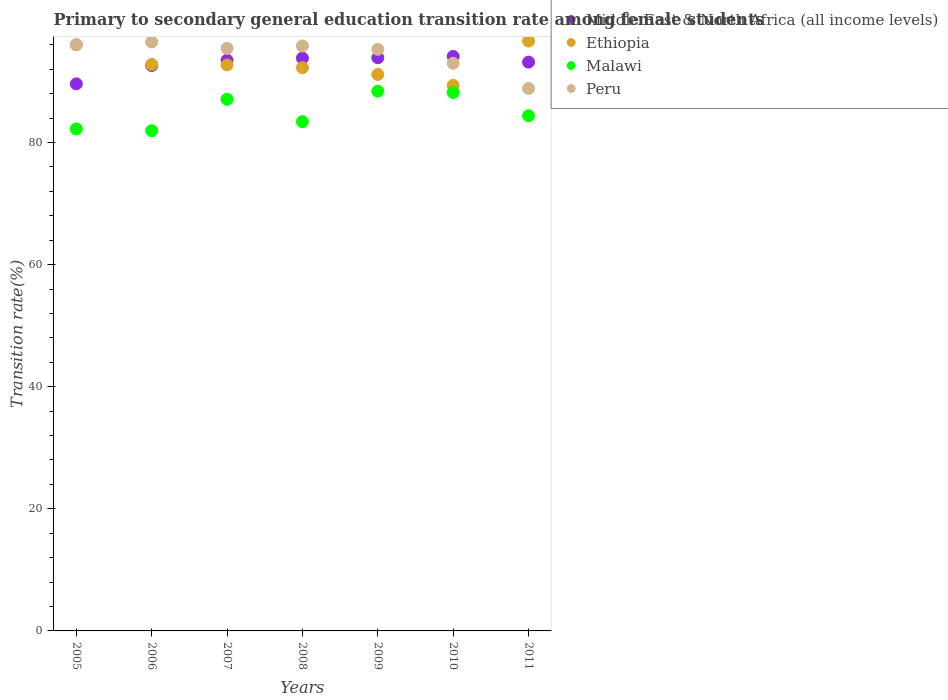How many different coloured dotlines are there?
Keep it short and to the point. 4. Is the number of dotlines equal to the number of legend labels?
Your answer should be compact. Yes. What is the transition rate in Peru in 2005?
Your answer should be compact. 96.03. Across all years, what is the maximum transition rate in Malawi?
Your answer should be very brief. 88.4. Across all years, what is the minimum transition rate in Ethiopia?
Offer a terse response. 89.35. In which year was the transition rate in Malawi maximum?
Ensure brevity in your answer.  2009. What is the total transition rate in Ethiopia in the graph?
Offer a terse response. 650.88. What is the difference between the transition rate in Middle East & North Africa (all income levels) in 2007 and that in 2008?
Your answer should be compact. -0.34. What is the difference between the transition rate in Middle East & North Africa (all income levels) in 2010 and the transition rate in Malawi in 2008?
Provide a short and direct response. 10.69. What is the average transition rate in Middle East & North Africa (all income levels) per year?
Provide a short and direct response. 92.96. In the year 2005, what is the difference between the transition rate in Malawi and transition rate in Ethiopia?
Make the answer very short. -13.78. In how many years, is the transition rate in Ethiopia greater than 48 %?
Offer a terse response. 7. What is the ratio of the transition rate in Peru in 2005 to that in 2007?
Offer a terse response. 1.01. Is the transition rate in Ethiopia in 2005 less than that in 2011?
Offer a terse response. Yes. What is the difference between the highest and the second highest transition rate in Malawi?
Offer a very short reply. 0.21. What is the difference between the highest and the lowest transition rate in Middle East & North Africa (all income levels)?
Your answer should be compact. 4.49. In how many years, is the transition rate in Malawi greater than the average transition rate in Malawi taken over all years?
Your answer should be very brief. 3. Is the sum of the transition rate in Malawi in 2009 and 2010 greater than the maximum transition rate in Peru across all years?
Offer a terse response. Yes. Is it the case that in every year, the sum of the transition rate in Peru and transition rate in Ethiopia  is greater than the sum of transition rate in Malawi and transition rate in Middle East & North Africa (all income levels)?
Offer a terse response. No. Is the transition rate in Ethiopia strictly less than the transition rate in Malawi over the years?
Provide a short and direct response. No. How many dotlines are there?
Offer a very short reply. 4. How many years are there in the graph?
Offer a terse response. 7. Are the values on the major ticks of Y-axis written in scientific E-notation?
Offer a terse response. No. Does the graph contain any zero values?
Offer a very short reply. No. Does the graph contain grids?
Provide a succinct answer. No. How are the legend labels stacked?
Your answer should be very brief. Vertical. What is the title of the graph?
Provide a succinct answer. Primary to secondary general education transition rate among female students. Does "Low income" appear as one of the legend labels in the graph?
Your answer should be very brief. No. What is the label or title of the Y-axis?
Keep it short and to the point. Transition rate(%). What is the Transition rate(%) in Middle East & North Africa (all income levels) in 2005?
Keep it short and to the point. 89.61. What is the Transition rate(%) of Ethiopia in 2005?
Make the answer very short. 96.01. What is the Transition rate(%) in Malawi in 2005?
Provide a short and direct response. 82.23. What is the Transition rate(%) of Peru in 2005?
Your response must be concise. 96.03. What is the Transition rate(%) in Middle East & North Africa (all income levels) in 2006?
Keep it short and to the point. 92.61. What is the Transition rate(%) in Ethiopia in 2006?
Offer a very short reply. 92.79. What is the Transition rate(%) of Malawi in 2006?
Provide a succinct answer. 81.94. What is the Transition rate(%) in Peru in 2006?
Make the answer very short. 96.47. What is the Transition rate(%) in Middle East & North Africa (all income levels) in 2007?
Keep it short and to the point. 93.48. What is the Transition rate(%) in Ethiopia in 2007?
Your response must be concise. 92.71. What is the Transition rate(%) of Malawi in 2007?
Make the answer very short. 87.08. What is the Transition rate(%) in Peru in 2007?
Your response must be concise. 95.42. What is the Transition rate(%) in Middle East & North Africa (all income levels) in 2008?
Offer a terse response. 93.82. What is the Transition rate(%) of Ethiopia in 2008?
Keep it short and to the point. 92.26. What is the Transition rate(%) in Malawi in 2008?
Provide a succinct answer. 83.41. What is the Transition rate(%) in Peru in 2008?
Keep it short and to the point. 95.81. What is the Transition rate(%) in Middle East & North Africa (all income levels) in 2009?
Your response must be concise. 93.88. What is the Transition rate(%) of Ethiopia in 2009?
Your response must be concise. 91.15. What is the Transition rate(%) of Malawi in 2009?
Provide a succinct answer. 88.4. What is the Transition rate(%) of Peru in 2009?
Offer a terse response. 95.26. What is the Transition rate(%) in Middle East & North Africa (all income levels) in 2010?
Make the answer very short. 94.11. What is the Transition rate(%) of Ethiopia in 2010?
Provide a short and direct response. 89.35. What is the Transition rate(%) in Malawi in 2010?
Ensure brevity in your answer.  88.19. What is the Transition rate(%) in Peru in 2010?
Your response must be concise. 92.99. What is the Transition rate(%) of Middle East & North Africa (all income levels) in 2011?
Give a very brief answer. 93.17. What is the Transition rate(%) in Ethiopia in 2011?
Keep it short and to the point. 96.62. What is the Transition rate(%) of Malawi in 2011?
Provide a short and direct response. 84.39. What is the Transition rate(%) in Peru in 2011?
Your response must be concise. 88.85. Across all years, what is the maximum Transition rate(%) of Middle East & North Africa (all income levels)?
Keep it short and to the point. 94.11. Across all years, what is the maximum Transition rate(%) of Ethiopia?
Provide a short and direct response. 96.62. Across all years, what is the maximum Transition rate(%) of Malawi?
Keep it short and to the point. 88.4. Across all years, what is the maximum Transition rate(%) of Peru?
Give a very brief answer. 96.47. Across all years, what is the minimum Transition rate(%) of Middle East & North Africa (all income levels)?
Provide a succinct answer. 89.61. Across all years, what is the minimum Transition rate(%) of Ethiopia?
Your answer should be compact. 89.35. Across all years, what is the minimum Transition rate(%) in Malawi?
Your answer should be compact. 81.94. Across all years, what is the minimum Transition rate(%) in Peru?
Keep it short and to the point. 88.85. What is the total Transition rate(%) of Middle East & North Africa (all income levels) in the graph?
Keep it short and to the point. 650.69. What is the total Transition rate(%) in Ethiopia in the graph?
Keep it short and to the point. 650.88. What is the total Transition rate(%) in Malawi in the graph?
Offer a terse response. 595.64. What is the total Transition rate(%) of Peru in the graph?
Your response must be concise. 660.83. What is the difference between the Transition rate(%) in Middle East & North Africa (all income levels) in 2005 and that in 2006?
Your response must be concise. -3. What is the difference between the Transition rate(%) of Ethiopia in 2005 and that in 2006?
Your response must be concise. 3.21. What is the difference between the Transition rate(%) in Malawi in 2005 and that in 2006?
Offer a terse response. 0.29. What is the difference between the Transition rate(%) of Peru in 2005 and that in 2006?
Offer a terse response. -0.44. What is the difference between the Transition rate(%) in Middle East & North Africa (all income levels) in 2005 and that in 2007?
Keep it short and to the point. -3.87. What is the difference between the Transition rate(%) in Ethiopia in 2005 and that in 2007?
Provide a short and direct response. 3.3. What is the difference between the Transition rate(%) in Malawi in 2005 and that in 2007?
Your response must be concise. -4.85. What is the difference between the Transition rate(%) of Peru in 2005 and that in 2007?
Your answer should be very brief. 0.61. What is the difference between the Transition rate(%) in Middle East & North Africa (all income levels) in 2005 and that in 2008?
Make the answer very short. -4.21. What is the difference between the Transition rate(%) of Ethiopia in 2005 and that in 2008?
Provide a short and direct response. 3.75. What is the difference between the Transition rate(%) of Malawi in 2005 and that in 2008?
Offer a very short reply. -1.18. What is the difference between the Transition rate(%) of Peru in 2005 and that in 2008?
Offer a terse response. 0.22. What is the difference between the Transition rate(%) in Middle East & North Africa (all income levels) in 2005 and that in 2009?
Make the answer very short. -4.27. What is the difference between the Transition rate(%) of Ethiopia in 2005 and that in 2009?
Make the answer very short. 4.86. What is the difference between the Transition rate(%) in Malawi in 2005 and that in 2009?
Offer a terse response. -6.17. What is the difference between the Transition rate(%) of Peru in 2005 and that in 2009?
Give a very brief answer. 0.77. What is the difference between the Transition rate(%) in Middle East & North Africa (all income levels) in 2005 and that in 2010?
Offer a terse response. -4.49. What is the difference between the Transition rate(%) of Ethiopia in 2005 and that in 2010?
Offer a terse response. 6.65. What is the difference between the Transition rate(%) of Malawi in 2005 and that in 2010?
Offer a terse response. -5.96. What is the difference between the Transition rate(%) of Peru in 2005 and that in 2010?
Provide a succinct answer. 3.04. What is the difference between the Transition rate(%) of Middle East & North Africa (all income levels) in 2005 and that in 2011?
Offer a very short reply. -3.56. What is the difference between the Transition rate(%) in Ethiopia in 2005 and that in 2011?
Your answer should be very brief. -0.61. What is the difference between the Transition rate(%) of Malawi in 2005 and that in 2011?
Ensure brevity in your answer.  -2.16. What is the difference between the Transition rate(%) of Peru in 2005 and that in 2011?
Offer a terse response. 7.18. What is the difference between the Transition rate(%) in Middle East & North Africa (all income levels) in 2006 and that in 2007?
Keep it short and to the point. -0.87. What is the difference between the Transition rate(%) of Ethiopia in 2006 and that in 2007?
Make the answer very short. 0.08. What is the difference between the Transition rate(%) in Malawi in 2006 and that in 2007?
Provide a short and direct response. -5.14. What is the difference between the Transition rate(%) of Peru in 2006 and that in 2007?
Your answer should be very brief. 1.05. What is the difference between the Transition rate(%) of Middle East & North Africa (all income levels) in 2006 and that in 2008?
Ensure brevity in your answer.  -1.21. What is the difference between the Transition rate(%) in Ethiopia in 2006 and that in 2008?
Provide a short and direct response. 0.53. What is the difference between the Transition rate(%) in Malawi in 2006 and that in 2008?
Your response must be concise. -1.47. What is the difference between the Transition rate(%) of Peru in 2006 and that in 2008?
Offer a terse response. 0.66. What is the difference between the Transition rate(%) of Middle East & North Africa (all income levels) in 2006 and that in 2009?
Provide a succinct answer. -1.27. What is the difference between the Transition rate(%) of Ethiopia in 2006 and that in 2009?
Make the answer very short. 1.65. What is the difference between the Transition rate(%) of Malawi in 2006 and that in 2009?
Provide a succinct answer. -6.46. What is the difference between the Transition rate(%) in Peru in 2006 and that in 2009?
Make the answer very short. 1.21. What is the difference between the Transition rate(%) in Middle East & North Africa (all income levels) in 2006 and that in 2010?
Provide a short and direct response. -1.49. What is the difference between the Transition rate(%) of Ethiopia in 2006 and that in 2010?
Keep it short and to the point. 3.44. What is the difference between the Transition rate(%) in Malawi in 2006 and that in 2010?
Give a very brief answer. -6.25. What is the difference between the Transition rate(%) of Peru in 2006 and that in 2010?
Provide a short and direct response. 3.48. What is the difference between the Transition rate(%) of Middle East & North Africa (all income levels) in 2006 and that in 2011?
Give a very brief answer. -0.56. What is the difference between the Transition rate(%) in Ethiopia in 2006 and that in 2011?
Provide a succinct answer. -3.83. What is the difference between the Transition rate(%) in Malawi in 2006 and that in 2011?
Make the answer very short. -2.45. What is the difference between the Transition rate(%) of Peru in 2006 and that in 2011?
Your answer should be compact. 7.62. What is the difference between the Transition rate(%) of Middle East & North Africa (all income levels) in 2007 and that in 2008?
Your answer should be very brief. -0.34. What is the difference between the Transition rate(%) in Ethiopia in 2007 and that in 2008?
Give a very brief answer. 0.45. What is the difference between the Transition rate(%) in Malawi in 2007 and that in 2008?
Offer a terse response. 3.67. What is the difference between the Transition rate(%) of Peru in 2007 and that in 2008?
Your answer should be compact. -0.39. What is the difference between the Transition rate(%) in Middle East & North Africa (all income levels) in 2007 and that in 2009?
Offer a terse response. -0.4. What is the difference between the Transition rate(%) in Ethiopia in 2007 and that in 2009?
Your answer should be very brief. 1.56. What is the difference between the Transition rate(%) in Malawi in 2007 and that in 2009?
Your answer should be compact. -1.33. What is the difference between the Transition rate(%) of Peru in 2007 and that in 2009?
Your answer should be compact. 0.16. What is the difference between the Transition rate(%) in Middle East & North Africa (all income levels) in 2007 and that in 2010?
Offer a very short reply. -0.62. What is the difference between the Transition rate(%) in Ethiopia in 2007 and that in 2010?
Your response must be concise. 3.36. What is the difference between the Transition rate(%) in Malawi in 2007 and that in 2010?
Your answer should be very brief. -1.11. What is the difference between the Transition rate(%) of Peru in 2007 and that in 2010?
Offer a very short reply. 2.43. What is the difference between the Transition rate(%) in Middle East & North Africa (all income levels) in 2007 and that in 2011?
Your answer should be compact. 0.31. What is the difference between the Transition rate(%) of Ethiopia in 2007 and that in 2011?
Your response must be concise. -3.91. What is the difference between the Transition rate(%) in Malawi in 2007 and that in 2011?
Keep it short and to the point. 2.69. What is the difference between the Transition rate(%) in Peru in 2007 and that in 2011?
Offer a terse response. 6.57. What is the difference between the Transition rate(%) in Middle East & North Africa (all income levels) in 2008 and that in 2009?
Provide a succinct answer. -0.06. What is the difference between the Transition rate(%) in Ethiopia in 2008 and that in 2009?
Ensure brevity in your answer.  1.11. What is the difference between the Transition rate(%) in Malawi in 2008 and that in 2009?
Provide a short and direct response. -4.99. What is the difference between the Transition rate(%) in Peru in 2008 and that in 2009?
Provide a short and direct response. 0.55. What is the difference between the Transition rate(%) in Middle East & North Africa (all income levels) in 2008 and that in 2010?
Give a very brief answer. -0.28. What is the difference between the Transition rate(%) of Ethiopia in 2008 and that in 2010?
Give a very brief answer. 2.91. What is the difference between the Transition rate(%) in Malawi in 2008 and that in 2010?
Provide a short and direct response. -4.78. What is the difference between the Transition rate(%) in Peru in 2008 and that in 2010?
Keep it short and to the point. 2.82. What is the difference between the Transition rate(%) in Middle East & North Africa (all income levels) in 2008 and that in 2011?
Offer a very short reply. 0.65. What is the difference between the Transition rate(%) in Ethiopia in 2008 and that in 2011?
Your response must be concise. -4.36. What is the difference between the Transition rate(%) of Malawi in 2008 and that in 2011?
Offer a very short reply. -0.98. What is the difference between the Transition rate(%) in Peru in 2008 and that in 2011?
Provide a short and direct response. 6.96. What is the difference between the Transition rate(%) of Middle East & North Africa (all income levels) in 2009 and that in 2010?
Your response must be concise. -0.22. What is the difference between the Transition rate(%) of Ethiopia in 2009 and that in 2010?
Ensure brevity in your answer.  1.79. What is the difference between the Transition rate(%) of Malawi in 2009 and that in 2010?
Offer a very short reply. 0.21. What is the difference between the Transition rate(%) in Peru in 2009 and that in 2010?
Give a very brief answer. 2.27. What is the difference between the Transition rate(%) in Middle East & North Africa (all income levels) in 2009 and that in 2011?
Keep it short and to the point. 0.71. What is the difference between the Transition rate(%) of Ethiopia in 2009 and that in 2011?
Offer a terse response. -5.47. What is the difference between the Transition rate(%) of Malawi in 2009 and that in 2011?
Your answer should be very brief. 4.02. What is the difference between the Transition rate(%) of Peru in 2009 and that in 2011?
Offer a terse response. 6.41. What is the difference between the Transition rate(%) of Middle East & North Africa (all income levels) in 2010 and that in 2011?
Offer a very short reply. 0.94. What is the difference between the Transition rate(%) in Ethiopia in 2010 and that in 2011?
Offer a very short reply. -7.27. What is the difference between the Transition rate(%) in Malawi in 2010 and that in 2011?
Ensure brevity in your answer.  3.8. What is the difference between the Transition rate(%) in Peru in 2010 and that in 2011?
Your response must be concise. 4.14. What is the difference between the Transition rate(%) in Middle East & North Africa (all income levels) in 2005 and the Transition rate(%) in Ethiopia in 2006?
Your answer should be very brief. -3.18. What is the difference between the Transition rate(%) in Middle East & North Africa (all income levels) in 2005 and the Transition rate(%) in Malawi in 2006?
Offer a very short reply. 7.67. What is the difference between the Transition rate(%) in Middle East & North Africa (all income levels) in 2005 and the Transition rate(%) in Peru in 2006?
Your answer should be very brief. -6.86. What is the difference between the Transition rate(%) of Ethiopia in 2005 and the Transition rate(%) of Malawi in 2006?
Offer a terse response. 14.07. What is the difference between the Transition rate(%) of Ethiopia in 2005 and the Transition rate(%) of Peru in 2006?
Your answer should be compact. -0.47. What is the difference between the Transition rate(%) of Malawi in 2005 and the Transition rate(%) of Peru in 2006?
Offer a very short reply. -14.24. What is the difference between the Transition rate(%) in Middle East & North Africa (all income levels) in 2005 and the Transition rate(%) in Ethiopia in 2007?
Provide a short and direct response. -3.1. What is the difference between the Transition rate(%) of Middle East & North Africa (all income levels) in 2005 and the Transition rate(%) of Malawi in 2007?
Offer a terse response. 2.53. What is the difference between the Transition rate(%) of Middle East & North Africa (all income levels) in 2005 and the Transition rate(%) of Peru in 2007?
Keep it short and to the point. -5.81. What is the difference between the Transition rate(%) in Ethiopia in 2005 and the Transition rate(%) in Malawi in 2007?
Your response must be concise. 8.93. What is the difference between the Transition rate(%) in Ethiopia in 2005 and the Transition rate(%) in Peru in 2007?
Make the answer very short. 0.59. What is the difference between the Transition rate(%) in Malawi in 2005 and the Transition rate(%) in Peru in 2007?
Provide a short and direct response. -13.19. What is the difference between the Transition rate(%) of Middle East & North Africa (all income levels) in 2005 and the Transition rate(%) of Ethiopia in 2008?
Your answer should be compact. -2.65. What is the difference between the Transition rate(%) in Middle East & North Africa (all income levels) in 2005 and the Transition rate(%) in Malawi in 2008?
Provide a short and direct response. 6.2. What is the difference between the Transition rate(%) in Middle East & North Africa (all income levels) in 2005 and the Transition rate(%) in Peru in 2008?
Provide a short and direct response. -6.2. What is the difference between the Transition rate(%) in Ethiopia in 2005 and the Transition rate(%) in Malawi in 2008?
Your answer should be very brief. 12.6. What is the difference between the Transition rate(%) in Ethiopia in 2005 and the Transition rate(%) in Peru in 2008?
Your response must be concise. 0.2. What is the difference between the Transition rate(%) in Malawi in 2005 and the Transition rate(%) in Peru in 2008?
Provide a short and direct response. -13.58. What is the difference between the Transition rate(%) in Middle East & North Africa (all income levels) in 2005 and the Transition rate(%) in Ethiopia in 2009?
Make the answer very short. -1.53. What is the difference between the Transition rate(%) of Middle East & North Africa (all income levels) in 2005 and the Transition rate(%) of Malawi in 2009?
Provide a succinct answer. 1.21. What is the difference between the Transition rate(%) in Middle East & North Africa (all income levels) in 2005 and the Transition rate(%) in Peru in 2009?
Offer a terse response. -5.65. What is the difference between the Transition rate(%) of Ethiopia in 2005 and the Transition rate(%) of Malawi in 2009?
Make the answer very short. 7.6. What is the difference between the Transition rate(%) in Ethiopia in 2005 and the Transition rate(%) in Peru in 2009?
Offer a terse response. 0.75. What is the difference between the Transition rate(%) in Malawi in 2005 and the Transition rate(%) in Peru in 2009?
Give a very brief answer. -13.03. What is the difference between the Transition rate(%) of Middle East & North Africa (all income levels) in 2005 and the Transition rate(%) of Ethiopia in 2010?
Offer a very short reply. 0.26. What is the difference between the Transition rate(%) in Middle East & North Africa (all income levels) in 2005 and the Transition rate(%) in Malawi in 2010?
Give a very brief answer. 1.42. What is the difference between the Transition rate(%) in Middle East & North Africa (all income levels) in 2005 and the Transition rate(%) in Peru in 2010?
Provide a short and direct response. -3.38. What is the difference between the Transition rate(%) in Ethiopia in 2005 and the Transition rate(%) in Malawi in 2010?
Make the answer very short. 7.81. What is the difference between the Transition rate(%) in Ethiopia in 2005 and the Transition rate(%) in Peru in 2010?
Keep it short and to the point. 3.02. What is the difference between the Transition rate(%) of Malawi in 2005 and the Transition rate(%) of Peru in 2010?
Give a very brief answer. -10.76. What is the difference between the Transition rate(%) in Middle East & North Africa (all income levels) in 2005 and the Transition rate(%) in Ethiopia in 2011?
Give a very brief answer. -7.01. What is the difference between the Transition rate(%) of Middle East & North Africa (all income levels) in 2005 and the Transition rate(%) of Malawi in 2011?
Your answer should be very brief. 5.22. What is the difference between the Transition rate(%) of Middle East & North Africa (all income levels) in 2005 and the Transition rate(%) of Peru in 2011?
Provide a succinct answer. 0.76. What is the difference between the Transition rate(%) in Ethiopia in 2005 and the Transition rate(%) in Malawi in 2011?
Ensure brevity in your answer.  11.62. What is the difference between the Transition rate(%) of Ethiopia in 2005 and the Transition rate(%) of Peru in 2011?
Your answer should be compact. 7.15. What is the difference between the Transition rate(%) of Malawi in 2005 and the Transition rate(%) of Peru in 2011?
Offer a very short reply. -6.62. What is the difference between the Transition rate(%) of Middle East & North Africa (all income levels) in 2006 and the Transition rate(%) of Ethiopia in 2007?
Offer a very short reply. -0.1. What is the difference between the Transition rate(%) of Middle East & North Africa (all income levels) in 2006 and the Transition rate(%) of Malawi in 2007?
Your answer should be compact. 5.54. What is the difference between the Transition rate(%) of Middle East & North Africa (all income levels) in 2006 and the Transition rate(%) of Peru in 2007?
Ensure brevity in your answer.  -2.81. What is the difference between the Transition rate(%) of Ethiopia in 2006 and the Transition rate(%) of Malawi in 2007?
Your response must be concise. 5.71. What is the difference between the Transition rate(%) in Ethiopia in 2006 and the Transition rate(%) in Peru in 2007?
Make the answer very short. -2.63. What is the difference between the Transition rate(%) in Malawi in 2006 and the Transition rate(%) in Peru in 2007?
Make the answer very short. -13.48. What is the difference between the Transition rate(%) in Middle East & North Africa (all income levels) in 2006 and the Transition rate(%) in Ethiopia in 2008?
Provide a short and direct response. 0.35. What is the difference between the Transition rate(%) of Middle East & North Africa (all income levels) in 2006 and the Transition rate(%) of Malawi in 2008?
Make the answer very short. 9.2. What is the difference between the Transition rate(%) of Middle East & North Africa (all income levels) in 2006 and the Transition rate(%) of Peru in 2008?
Provide a short and direct response. -3.2. What is the difference between the Transition rate(%) in Ethiopia in 2006 and the Transition rate(%) in Malawi in 2008?
Offer a very short reply. 9.38. What is the difference between the Transition rate(%) of Ethiopia in 2006 and the Transition rate(%) of Peru in 2008?
Offer a very short reply. -3.02. What is the difference between the Transition rate(%) in Malawi in 2006 and the Transition rate(%) in Peru in 2008?
Your answer should be compact. -13.87. What is the difference between the Transition rate(%) in Middle East & North Africa (all income levels) in 2006 and the Transition rate(%) in Ethiopia in 2009?
Provide a short and direct response. 1.47. What is the difference between the Transition rate(%) in Middle East & North Africa (all income levels) in 2006 and the Transition rate(%) in Malawi in 2009?
Your answer should be very brief. 4.21. What is the difference between the Transition rate(%) in Middle East & North Africa (all income levels) in 2006 and the Transition rate(%) in Peru in 2009?
Offer a very short reply. -2.65. What is the difference between the Transition rate(%) in Ethiopia in 2006 and the Transition rate(%) in Malawi in 2009?
Make the answer very short. 4.39. What is the difference between the Transition rate(%) of Ethiopia in 2006 and the Transition rate(%) of Peru in 2009?
Give a very brief answer. -2.47. What is the difference between the Transition rate(%) in Malawi in 2006 and the Transition rate(%) in Peru in 2009?
Keep it short and to the point. -13.32. What is the difference between the Transition rate(%) of Middle East & North Africa (all income levels) in 2006 and the Transition rate(%) of Ethiopia in 2010?
Your answer should be very brief. 3.26. What is the difference between the Transition rate(%) of Middle East & North Africa (all income levels) in 2006 and the Transition rate(%) of Malawi in 2010?
Make the answer very short. 4.42. What is the difference between the Transition rate(%) in Middle East & North Africa (all income levels) in 2006 and the Transition rate(%) in Peru in 2010?
Your answer should be very brief. -0.38. What is the difference between the Transition rate(%) of Ethiopia in 2006 and the Transition rate(%) of Malawi in 2010?
Offer a terse response. 4.6. What is the difference between the Transition rate(%) in Ethiopia in 2006 and the Transition rate(%) in Peru in 2010?
Give a very brief answer. -0.2. What is the difference between the Transition rate(%) of Malawi in 2006 and the Transition rate(%) of Peru in 2010?
Offer a terse response. -11.05. What is the difference between the Transition rate(%) in Middle East & North Africa (all income levels) in 2006 and the Transition rate(%) in Ethiopia in 2011?
Offer a terse response. -4. What is the difference between the Transition rate(%) in Middle East & North Africa (all income levels) in 2006 and the Transition rate(%) in Malawi in 2011?
Ensure brevity in your answer.  8.22. What is the difference between the Transition rate(%) in Middle East & North Africa (all income levels) in 2006 and the Transition rate(%) in Peru in 2011?
Your answer should be compact. 3.76. What is the difference between the Transition rate(%) of Ethiopia in 2006 and the Transition rate(%) of Malawi in 2011?
Your answer should be compact. 8.4. What is the difference between the Transition rate(%) of Ethiopia in 2006 and the Transition rate(%) of Peru in 2011?
Your response must be concise. 3.94. What is the difference between the Transition rate(%) of Malawi in 2006 and the Transition rate(%) of Peru in 2011?
Your answer should be compact. -6.91. What is the difference between the Transition rate(%) in Middle East & North Africa (all income levels) in 2007 and the Transition rate(%) in Ethiopia in 2008?
Provide a short and direct response. 1.22. What is the difference between the Transition rate(%) of Middle East & North Africa (all income levels) in 2007 and the Transition rate(%) of Malawi in 2008?
Offer a very short reply. 10.07. What is the difference between the Transition rate(%) in Middle East & North Africa (all income levels) in 2007 and the Transition rate(%) in Peru in 2008?
Your response must be concise. -2.33. What is the difference between the Transition rate(%) in Ethiopia in 2007 and the Transition rate(%) in Malawi in 2008?
Ensure brevity in your answer.  9.3. What is the difference between the Transition rate(%) in Ethiopia in 2007 and the Transition rate(%) in Peru in 2008?
Provide a short and direct response. -3.1. What is the difference between the Transition rate(%) in Malawi in 2007 and the Transition rate(%) in Peru in 2008?
Offer a terse response. -8.73. What is the difference between the Transition rate(%) of Middle East & North Africa (all income levels) in 2007 and the Transition rate(%) of Ethiopia in 2009?
Your response must be concise. 2.34. What is the difference between the Transition rate(%) of Middle East & North Africa (all income levels) in 2007 and the Transition rate(%) of Malawi in 2009?
Your answer should be compact. 5.08. What is the difference between the Transition rate(%) of Middle East & North Africa (all income levels) in 2007 and the Transition rate(%) of Peru in 2009?
Offer a very short reply. -1.78. What is the difference between the Transition rate(%) of Ethiopia in 2007 and the Transition rate(%) of Malawi in 2009?
Offer a very short reply. 4.31. What is the difference between the Transition rate(%) of Ethiopia in 2007 and the Transition rate(%) of Peru in 2009?
Your answer should be compact. -2.55. What is the difference between the Transition rate(%) in Malawi in 2007 and the Transition rate(%) in Peru in 2009?
Provide a succinct answer. -8.18. What is the difference between the Transition rate(%) of Middle East & North Africa (all income levels) in 2007 and the Transition rate(%) of Ethiopia in 2010?
Make the answer very short. 4.13. What is the difference between the Transition rate(%) in Middle East & North Africa (all income levels) in 2007 and the Transition rate(%) in Malawi in 2010?
Your answer should be very brief. 5.29. What is the difference between the Transition rate(%) of Middle East & North Africa (all income levels) in 2007 and the Transition rate(%) of Peru in 2010?
Ensure brevity in your answer.  0.49. What is the difference between the Transition rate(%) of Ethiopia in 2007 and the Transition rate(%) of Malawi in 2010?
Give a very brief answer. 4.52. What is the difference between the Transition rate(%) in Ethiopia in 2007 and the Transition rate(%) in Peru in 2010?
Provide a short and direct response. -0.28. What is the difference between the Transition rate(%) in Malawi in 2007 and the Transition rate(%) in Peru in 2010?
Give a very brief answer. -5.91. What is the difference between the Transition rate(%) of Middle East & North Africa (all income levels) in 2007 and the Transition rate(%) of Ethiopia in 2011?
Make the answer very short. -3.13. What is the difference between the Transition rate(%) of Middle East & North Africa (all income levels) in 2007 and the Transition rate(%) of Malawi in 2011?
Your answer should be very brief. 9.1. What is the difference between the Transition rate(%) in Middle East & North Africa (all income levels) in 2007 and the Transition rate(%) in Peru in 2011?
Your answer should be compact. 4.63. What is the difference between the Transition rate(%) of Ethiopia in 2007 and the Transition rate(%) of Malawi in 2011?
Offer a terse response. 8.32. What is the difference between the Transition rate(%) of Ethiopia in 2007 and the Transition rate(%) of Peru in 2011?
Provide a short and direct response. 3.86. What is the difference between the Transition rate(%) of Malawi in 2007 and the Transition rate(%) of Peru in 2011?
Provide a short and direct response. -1.77. What is the difference between the Transition rate(%) of Middle East & North Africa (all income levels) in 2008 and the Transition rate(%) of Ethiopia in 2009?
Ensure brevity in your answer.  2.68. What is the difference between the Transition rate(%) of Middle East & North Africa (all income levels) in 2008 and the Transition rate(%) of Malawi in 2009?
Offer a terse response. 5.42. What is the difference between the Transition rate(%) in Middle East & North Africa (all income levels) in 2008 and the Transition rate(%) in Peru in 2009?
Offer a very short reply. -1.44. What is the difference between the Transition rate(%) in Ethiopia in 2008 and the Transition rate(%) in Malawi in 2009?
Keep it short and to the point. 3.86. What is the difference between the Transition rate(%) in Ethiopia in 2008 and the Transition rate(%) in Peru in 2009?
Offer a very short reply. -3. What is the difference between the Transition rate(%) in Malawi in 2008 and the Transition rate(%) in Peru in 2009?
Give a very brief answer. -11.85. What is the difference between the Transition rate(%) of Middle East & North Africa (all income levels) in 2008 and the Transition rate(%) of Ethiopia in 2010?
Your answer should be very brief. 4.47. What is the difference between the Transition rate(%) of Middle East & North Africa (all income levels) in 2008 and the Transition rate(%) of Malawi in 2010?
Ensure brevity in your answer.  5.63. What is the difference between the Transition rate(%) of Middle East & North Africa (all income levels) in 2008 and the Transition rate(%) of Peru in 2010?
Your answer should be very brief. 0.83. What is the difference between the Transition rate(%) in Ethiopia in 2008 and the Transition rate(%) in Malawi in 2010?
Offer a terse response. 4.07. What is the difference between the Transition rate(%) of Ethiopia in 2008 and the Transition rate(%) of Peru in 2010?
Make the answer very short. -0.73. What is the difference between the Transition rate(%) of Malawi in 2008 and the Transition rate(%) of Peru in 2010?
Make the answer very short. -9.58. What is the difference between the Transition rate(%) of Middle East & North Africa (all income levels) in 2008 and the Transition rate(%) of Ethiopia in 2011?
Give a very brief answer. -2.8. What is the difference between the Transition rate(%) of Middle East & North Africa (all income levels) in 2008 and the Transition rate(%) of Malawi in 2011?
Your answer should be very brief. 9.43. What is the difference between the Transition rate(%) of Middle East & North Africa (all income levels) in 2008 and the Transition rate(%) of Peru in 2011?
Keep it short and to the point. 4.97. What is the difference between the Transition rate(%) of Ethiopia in 2008 and the Transition rate(%) of Malawi in 2011?
Ensure brevity in your answer.  7.87. What is the difference between the Transition rate(%) in Ethiopia in 2008 and the Transition rate(%) in Peru in 2011?
Make the answer very short. 3.41. What is the difference between the Transition rate(%) in Malawi in 2008 and the Transition rate(%) in Peru in 2011?
Offer a terse response. -5.44. What is the difference between the Transition rate(%) in Middle East & North Africa (all income levels) in 2009 and the Transition rate(%) in Ethiopia in 2010?
Give a very brief answer. 4.53. What is the difference between the Transition rate(%) in Middle East & North Africa (all income levels) in 2009 and the Transition rate(%) in Malawi in 2010?
Your answer should be compact. 5.69. What is the difference between the Transition rate(%) in Middle East & North Africa (all income levels) in 2009 and the Transition rate(%) in Peru in 2010?
Offer a terse response. 0.9. What is the difference between the Transition rate(%) of Ethiopia in 2009 and the Transition rate(%) of Malawi in 2010?
Your response must be concise. 2.95. What is the difference between the Transition rate(%) of Ethiopia in 2009 and the Transition rate(%) of Peru in 2010?
Keep it short and to the point. -1.84. What is the difference between the Transition rate(%) in Malawi in 2009 and the Transition rate(%) in Peru in 2010?
Your answer should be very brief. -4.58. What is the difference between the Transition rate(%) of Middle East & North Africa (all income levels) in 2009 and the Transition rate(%) of Ethiopia in 2011?
Your answer should be very brief. -2.73. What is the difference between the Transition rate(%) in Middle East & North Africa (all income levels) in 2009 and the Transition rate(%) in Malawi in 2011?
Give a very brief answer. 9.5. What is the difference between the Transition rate(%) in Middle East & North Africa (all income levels) in 2009 and the Transition rate(%) in Peru in 2011?
Offer a very short reply. 5.03. What is the difference between the Transition rate(%) of Ethiopia in 2009 and the Transition rate(%) of Malawi in 2011?
Ensure brevity in your answer.  6.76. What is the difference between the Transition rate(%) of Ethiopia in 2009 and the Transition rate(%) of Peru in 2011?
Ensure brevity in your answer.  2.29. What is the difference between the Transition rate(%) in Malawi in 2009 and the Transition rate(%) in Peru in 2011?
Offer a terse response. -0.45. What is the difference between the Transition rate(%) in Middle East & North Africa (all income levels) in 2010 and the Transition rate(%) in Ethiopia in 2011?
Make the answer very short. -2.51. What is the difference between the Transition rate(%) in Middle East & North Africa (all income levels) in 2010 and the Transition rate(%) in Malawi in 2011?
Ensure brevity in your answer.  9.72. What is the difference between the Transition rate(%) of Middle East & North Africa (all income levels) in 2010 and the Transition rate(%) of Peru in 2011?
Provide a short and direct response. 5.25. What is the difference between the Transition rate(%) in Ethiopia in 2010 and the Transition rate(%) in Malawi in 2011?
Offer a very short reply. 4.96. What is the difference between the Transition rate(%) of Ethiopia in 2010 and the Transition rate(%) of Peru in 2011?
Ensure brevity in your answer.  0.5. What is the difference between the Transition rate(%) in Malawi in 2010 and the Transition rate(%) in Peru in 2011?
Provide a succinct answer. -0.66. What is the average Transition rate(%) in Middle East & North Africa (all income levels) per year?
Give a very brief answer. 92.96. What is the average Transition rate(%) of Ethiopia per year?
Offer a terse response. 92.98. What is the average Transition rate(%) of Malawi per year?
Provide a succinct answer. 85.09. What is the average Transition rate(%) of Peru per year?
Make the answer very short. 94.4. In the year 2005, what is the difference between the Transition rate(%) in Middle East & North Africa (all income levels) and Transition rate(%) in Ethiopia?
Provide a short and direct response. -6.4. In the year 2005, what is the difference between the Transition rate(%) of Middle East & North Africa (all income levels) and Transition rate(%) of Malawi?
Keep it short and to the point. 7.38. In the year 2005, what is the difference between the Transition rate(%) in Middle East & North Africa (all income levels) and Transition rate(%) in Peru?
Give a very brief answer. -6.42. In the year 2005, what is the difference between the Transition rate(%) in Ethiopia and Transition rate(%) in Malawi?
Your answer should be compact. 13.78. In the year 2005, what is the difference between the Transition rate(%) of Ethiopia and Transition rate(%) of Peru?
Provide a short and direct response. -0.02. In the year 2005, what is the difference between the Transition rate(%) in Malawi and Transition rate(%) in Peru?
Offer a terse response. -13.8. In the year 2006, what is the difference between the Transition rate(%) in Middle East & North Africa (all income levels) and Transition rate(%) in Ethiopia?
Make the answer very short. -0.18. In the year 2006, what is the difference between the Transition rate(%) in Middle East & North Africa (all income levels) and Transition rate(%) in Malawi?
Your response must be concise. 10.67. In the year 2006, what is the difference between the Transition rate(%) of Middle East & North Africa (all income levels) and Transition rate(%) of Peru?
Your answer should be compact. -3.86. In the year 2006, what is the difference between the Transition rate(%) of Ethiopia and Transition rate(%) of Malawi?
Your answer should be very brief. 10.85. In the year 2006, what is the difference between the Transition rate(%) in Ethiopia and Transition rate(%) in Peru?
Give a very brief answer. -3.68. In the year 2006, what is the difference between the Transition rate(%) of Malawi and Transition rate(%) of Peru?
Make the answer very short. -14.53. In the year 2007, what is the difference between the Transition rate(%) in Middle East & North Africa (all income levels) and Transition rate(%) in Ethiopia?
Keep it short and to the point. 0.77. In the year 2007, what is the difference between the Transition rate(%) of Middle East & North Africa (all income levels) and Transition rate(%) of Malawi?
Offer a very short reply. 6.41. In the year 2007, what is the difference between the Transition rate(%) in Middle East & North Africa (all income levels) and Transition rate(%) in Peru?
Your answer should be compact. -1.94. In the year 2007, what is the difference between the Transition rate(%) in Ethiopia and Transition rate(%) in Malawi?
Offer a terse response. 5.63. In the year 2007, what is the difference between the Transition rate(%) in Ethiopia and Transition rate(%) in Peru?
Your response must be concise. -2.71. In the year 2007, what is the difference between the Transition rate(%) of Malawi and Transition rate(%) of Peru?
Give a very brief answer. -8.34. In the year 2008, what is the difference between the Transition rate(%) in Middle East & North Africa (all income levels) and Transition rate(%) in Ethiopia?
Provide a succinct answer. 1.56. In the year 2008, what is the difference between the Transition rate(%) of Middle East & North Africa (all income levels) and Transition rate(%) of Malawi?
Provide a succinct answer. 10.41. In the year 2008, what is the difference between the Transition rate(%) in Middle East & North Africa (all income levels) and Transition rate(%) in Peru?
Your answer should be very brief. -1.99. In the year 2008, what is the difference between the Transition rate(%) of Ethiopia and Transition rate(%) of Malawi?
Your response must be concise. 8.85. In the year 2008, what is the difference between the Transition rate(%) in Ethiopia and Transition rate(%) in Peru?
Offer a very short reply. -3.55. In the year 2008, what is the difference between the Transition rate(%) of Malawi and Transition rate(%) of Peru?
Your answer should be compact. -12.4. In the year 2009, what is the difference between the Transition rate(%) in Middle East & North Africa (all income levels) and Transition rate(%) in Ethiopia?
Provide a short and direct response. 2.74. In the year 2009, what is the difference between the Transition rate(%) of Middle East & North Africa (all income levels) and Transition rate(%) of Malawi?
Your answer should be compact. 5.48. In the year 2009, what is the difference between the Transition rate(%) of Middle East & North Africa (all income levels) and Transition rate(%) of Peru?
Provide a succinct answer. -1.37. In the year 2009, what is the difference between the Transition rate(%) in Ethiopia and Transition rate(%) in Malawi?
Your answer should be very brief. 2.74. In the year 2009, what is the difference between the Transition rate(%) in Ethiopia and Transition rate(%) in Peru?
Your answer should be very brief. -4.11. In the year 2009, what is the difference between the Transition rate(%) in Malawi and Transition rate(%) in Peru?
Your response must be concise. -6.85. In the year 2010, what is the difference between the Transition rate(%) in Middle East & North Africa (all income levels) and Transition rate(%) in Ethiopia?
Ensure brevity in your answer.  4.75. In the year 2010, what is the difference between the Transition rate(%) in Middle East & North Africa (all income levels) and Transition rate(%) in Malawi?
Your answer should be very brief. 5.91. In the year 2010, what is the difference between the Transition rate(%) of Middle East & North Africa (all income levels) and Transition rate(%) of Peru?
Provide a succinct answer. 1.12. In the year 2010, what is the difference between the Transition rate(%) in Ethiopia and Transition rate(%) in Malawi?
Your response must be concise. 1.16. In the year 2010, what is the difference between the Transition rate(%) in Ethiopia and Transition rate(%) in Peru?
Provide a short and direct response. -3.64. In the year 2010, what is the difference between the Transition rate(%) of Malawi and Transition rate(%) of Peru?
Provide a succinct answer. -4.8. In the year 2011, what is the difference between the Transition rate(%) in Middle East & North Africa (all income levels) and Transition rate(%) in Ethiopia?
Offer a terse response. -3.45. In the year 2011, what is the difference between the Transition rate(%) in Middle East & North Africa (all income levels) and Transition rate(%) in Malawi?
Provide a succinct answer. 8.78. In the year 2011, what is the difference between the Transition rate(%) of Middle East & North Africa (all income levels) and Transition rate(%) of Peru?
Keep it short and to the point. 4.32. In the year 2011, what is the difference between the Transition rate(%) of Ethiopia and Transition rate(%) of Malawi?
Make the answer very short. 12.23. In the year 2011, what is the difference between the Transition rate(%) of Ethiopia and Transition rate(%) of Peru?
Your answer should be compact. 7.77. In the year 2011, what is the difference between the Transition rate(%) in Malawi and Transition rate(%) in Peru?
Give a very brief answer. -4.46. What is the ratio of the Transition rate(%) in Middle East & North Africa (all income levels) in 2005 to that in 2006?
Keep it short and to the point. 0.97. What is the ratio of the Transition rate(%) of Ethiopia in 2005 to that in 2006?
Provide a succinct answer. 1.03. What is the ratio of the Transition rate(%) of Peru in 2005 to that in 2006?
Provide a succinct answer. 1. What is the ratio of the Transition rate(%) of Middle East & North Africa (all income levels) in 2005 to that in 2007?
Your response must be concise. 0.96. What is the ratio of the Transition rate(%) of Ethiopia in 2005 to that in 2007?
Your response must be concise. 1.04. What is the ratio of the Transition rate(%) in Malawi in 2005 to that in 2007?
Offer a terse response. 0.94. What is the ratio of the Transition rate(%) in Peru in 2005 to that in 2007?
Provide a succinct answer. 1.01. What is the ratio of the Transition rate(%) in Middle East & North Africa (all income levels) in 2005 to that in 2008?
Ensure brevity in your answer.  0.96. What is the ratio of the Transition rate(%) of Ethiopia in 2005 to that in 2008?
Offer a very short reply. 1.04. What is the ratio of the Transition rate(%) of Malawi in 2005 to that in 2008?
Give a very brief answer. 0.99. What is the ratio of the Transition rate(%) of Peru in 2005 to that in 2008?
Ensure brevity in your answer.  1. What is the ratio of the Transition rate(%) of Middle East & North Africa (all income levels) in 2005 to that in 2009?
Provide a short and direct response. 0.95. What is the ratio of the Transition rate(%) in Ethiopia in 2005 to that in 2009?
Your response must be concise. 1.05. What is the ratio of the Transition rate(%) in Malawi in 2005 to that in 2009?
Keep it short and to the point. 0.93. What is the ratio of the Transition rate(%) of Middle East & North Africa (all income levels) in 2005 to that in 2010?
Provide a short and direct response. 0.95. What is the ratio of the Transition rate(%) in Ethiopia in 2005 to that in 2010?
Your answer should be very brief. 1.07. What is the ratio of the Transition rate(%) of Malawi in 2005 to that in 2010?
Your answer should be compact. 0.93. What is the ratio of the Transition rate(%) in Peru in 2005 to that in 2010?
Provide a succinct answer. 1.03. What is the ratio of the Transition rate(%) in Middle East & North Africa (all income levels) in 2005 to that in 2011?
Make the answer very short. 0.96. What is the ratio of the Transition rate(%) in Ethiopia in 2005 to that in 2011?
Your answer should be very brief. 0.99. What is the ratio of the Transition rate(%) in Malawi in 2005 to that in 2011?
Offer a terse response. 0.97. What is the ratio of the Transition rate(%) of Peru in 2005 to that in 2011?
Keep it short and to the point. 1.08. What is the ratio of the Transition rate(%) of Middle East & North Africa (all income levels) in 2006 to that in 2007?
Make the answer very short. 0.99. What is the ratio of the Transition rate(%) in Ethiopia in 2006 to that in 2007?
Provide a short and direct response. 1. What is the ratio of the Transition rate(%) in Malawi in 2006 to that in 2007?
Give a very brief answer. 0.94. What is the ratio of the Transition rate(%) of Middle East & North Africa (all income levels) in 2006 to that in 2008?
Your answer should be very brief. 0.99. What is the ratio of the Transition rate(%) of Ethiopia in 2006 to that in 2008?
Your response must be concise. 1.01. What is the ratio of the Transition rate(%) of Malawi in 2006 to that in 2008?
Your answer should be compact. 0.98. What is the ratio of the Transition rate(%) of Middle East & North Africa (all income levels) in 2006 to that in 2009?
Give a very brief answer. 0.99. What is the ratio of the Transition rate(%) in Ethiopia in 2006 to that in 2009?
Ensure brevity in your answer.  1.02. What is the ratio of the Transition rate(%) of Malawi in 2006 to that in 2009?
Provide a short and direct response. 0.93. What is the ratio of the Transition rate(%) in Peru in 2006 to that in 2009?
Keep it short and to the point. 1.01. What is the ratio of the Transition rate(%) of Middle East & North Africa (all income levels) in 2006 to that in 2010?
Keep it short and to the point. 0.98. What is the ratio of the Transition rate(%) in Malawi in 2006 to that in 2010?
Your response must be concise. 0.93. What is the ratio of the Transition rate(%) of Peru in 2006 to that in 2010?
Give a very brief answer. 1.04. What is the ratio of the Transition rate(%) in Ethiopia in 2006 to that in 2011?
Your answer should be compact. 0.96. What is the ratio of the Transition rate(%) in Malawi in 2006 to that in 2011?
Your response must be concise. 0.97. What is the ratio of the Transition rate(%) in Peru in 2006 to that in 2011?
Keep it short and to the point. 1.09. What is the ratio of the Transition rate(%) in Ethiopia in 2007 to that in 2008?
Keep it short and to the point. 1. What is the ratio of the Transition rate(%) in Malawi in 2007 to that in 2008?
Your response must be concise. 1.04. What is the ratio of the Transition rate(%) in Peru in 2007 to that in 2008?
Provide a short and direct response. 1. What is the ratio of the Transition rate(%) in Middle East & North Africa (all income levels) in 2007 to that in 2009?
Make the answer very short. 1. What is the ratio of the Transition rate(%) in Ethiopia in 2007 to that in 2009?
Ensure brevity in your answer.  1.02. What is the ratio of the Transition rate(%) of Malawi in 2007 to that in 2009?
Your response must be concise. 0.98. What is the ratio of the Transition rate(%) of Ethiopia in 2007 to that in 2010?
Make the answer very short. 1.04. What is the ratio of the Transition rate(%) of Malawi in 2007 to that in 2010?
Keep it short and to the point. 0.99. What is the ratio of the Transition rate(%) in Peru in 2007 to that in 2010?
Offer a terse response. 1.03. What is the ratio of the Transition rate(%) of Middle East & North Africa (all income levels) in 2007 to that in 2011?
Your response must be concise. 1. What is the ratio of the Transition rate(%) in Ethiopia in 2007 to that in 2011?
Your answer should be compact. 0.96. What is the ratio of the Transition rate(%) of Malawi in 2007 to that in 2011?
Make the answer very short. 1.03. What is the ratio of the Transition rate(%) of Peru in 2007 to that in 2011?
Provide a succinct answer. 1.07. What is the ratio of the Transition rate(%) in Middle East & North Africa (all income levels) in 2008 to that in 2009?
Your answer should be very brief. 1. What is the ratio of the Transition rate(%) in Ethiopia in 2008 to that in 2009?
Ensure brevity in your answer.  1.01. What is the ratio of the Transition rate(%) in Malawi in 2008 to that in 2009?
Your response must be concise. 0.94. What is the ratio of the Transition rate(%) in Peru in 2008 to that in 2009?
Make the answer very short. 1.01. What is the ratio of the Transition rate(%) of Ethiopia in 2008 to that in 2010?
Provide a short and direct response. 1.03. What is the ratio of the Transition rate(%) of Malawi in 2008 to that in 2010?
Keep it short and to the point. 0.95. What is the ratio of the Transition rate(%) in Peru in 2008 to that in 2010?
Offer a very short reply. 1.03. What is the ratio of the Transition rate(%) of Middle East & North Africa (all income levels) in 2008 to that in 2011?
Your response must be concise. 1.01. What is the ratio of the Transition rate(%) in Ethiopia in 2008 to that in 2011?
Your response must be concise. 0.95. What is the ratio of the Transition rate(%) in Malawi in 2008 to that in 2011?
Keep it short and to the point. 0.99. What is the ratio of the Transition rate(%) of Peru in 2008 to that in 2011?
Make the answer very short. 1.08. What is the ratio of the Transition rate(%) of Ethiopia in 2009 to that in 2010?
Ensure brevity in your answer.  1.02. What is the ratio of the Transition rate(%) of Malawi in 2009 to that in 2010?
Ensure brevity in your answer.  1. What is the ratio of the Transition rate(%) in Peru in 2009 to that in 2010?
Your answer should be very brief. 1.02. What is the ratio of the Transition rate(%) of Middle East & North Africa (all income levels) in 2009 to that in 2011?
Provide a succinct answer. 1.01. What is the ratio of the Transition rate(%) of Ethiopia in 2009 to that in 2011?
Offer a very short reply. 0.94. What is the ratio of the Transition rate(%) of Malawi in 2009 to that in 2011?
Your answer should be very brief. 1.05. What is the ratio of the Transition rate(%) in Peru in 2009 to that in 2011?
Your response must be concise. 1.07. What is the ratio of the Transition rate(%) in Ethiopia in 2010 to that in 2011?
Your answer should be very brief. 0.92. What is the ratio of the Transition rate(%) of Malawi in 2010 to that in 2011?
Offer a terse response. 1.05. What is the ratio of the Transition rate(%) of Peru in 2010 to that in 2011?
Your answer should be compact. 1.05. What is the difference between the highest and the second highest Transition rate(%) in Middle East & North Africa (all income levels)?
Provide a succinct answer. 0.22. What is the difference between the highest and the second highest Transition rate(%) of Ethiopia?
Provide a short and direct response. 0.61. What is the difference between the highest and the second highest Transition rate(%) in Malawi?
Provide a short and direct response. 0.21. What is the difference between the highest and the second highest Transition rate(%) of Peru?
Your response must be concise. 0.44. What is the difference between the highest and the lowest Transition rate(%) in Middle East & North Africa (all income levels)?
Provide a short and direct response. 4.49. What is the difference between the highest and the lowest Transition rate(%) in Ethiopia?
Your response must be concise. 7.27. What is the difference between the highest and the lowest Transition rate(%) in Malawi?
Ensure brevity in your answer.  6.46. What is the difference between the highest and the lowest Transition rate(%) of Peru?
Your answer should be very brief. 7.62. 